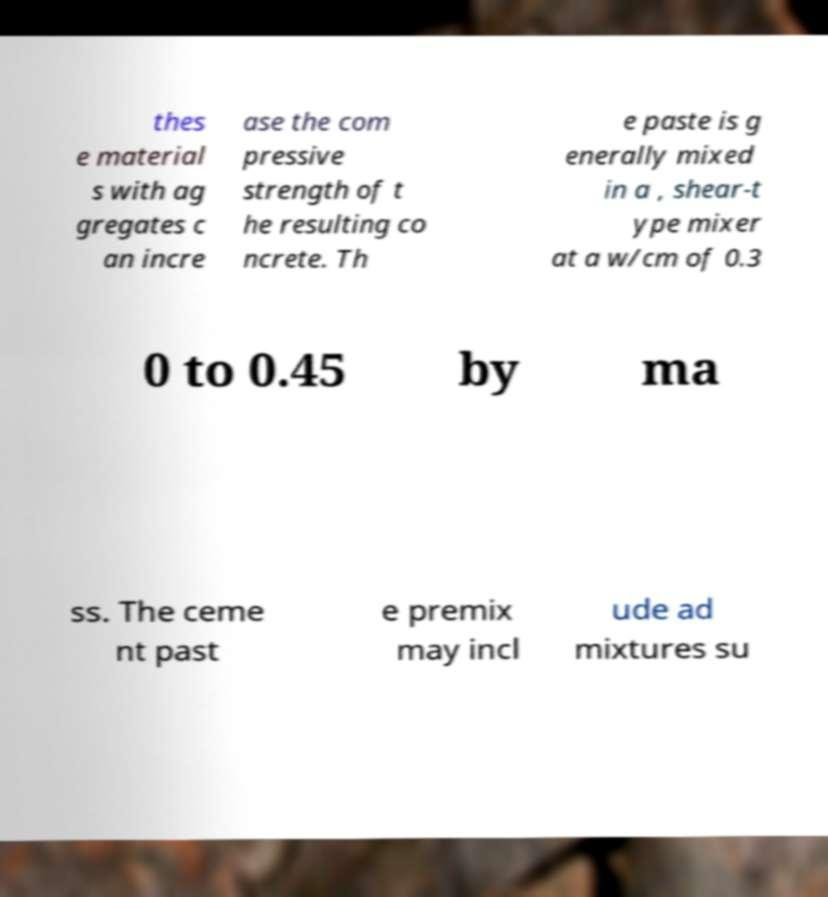Could you assist in decoding the text presented in this image and type it out clearly? thes e material s with ag gregates c an incre ase the com pressive strength of t he resulting co ncrete. Th e paste is g enerally mixed in a , shear-t ype mixer at a w/cm of 0.3 0 to 0.45 by ma ss. The ceme nt past e premix may incl ude ad mixtures su 